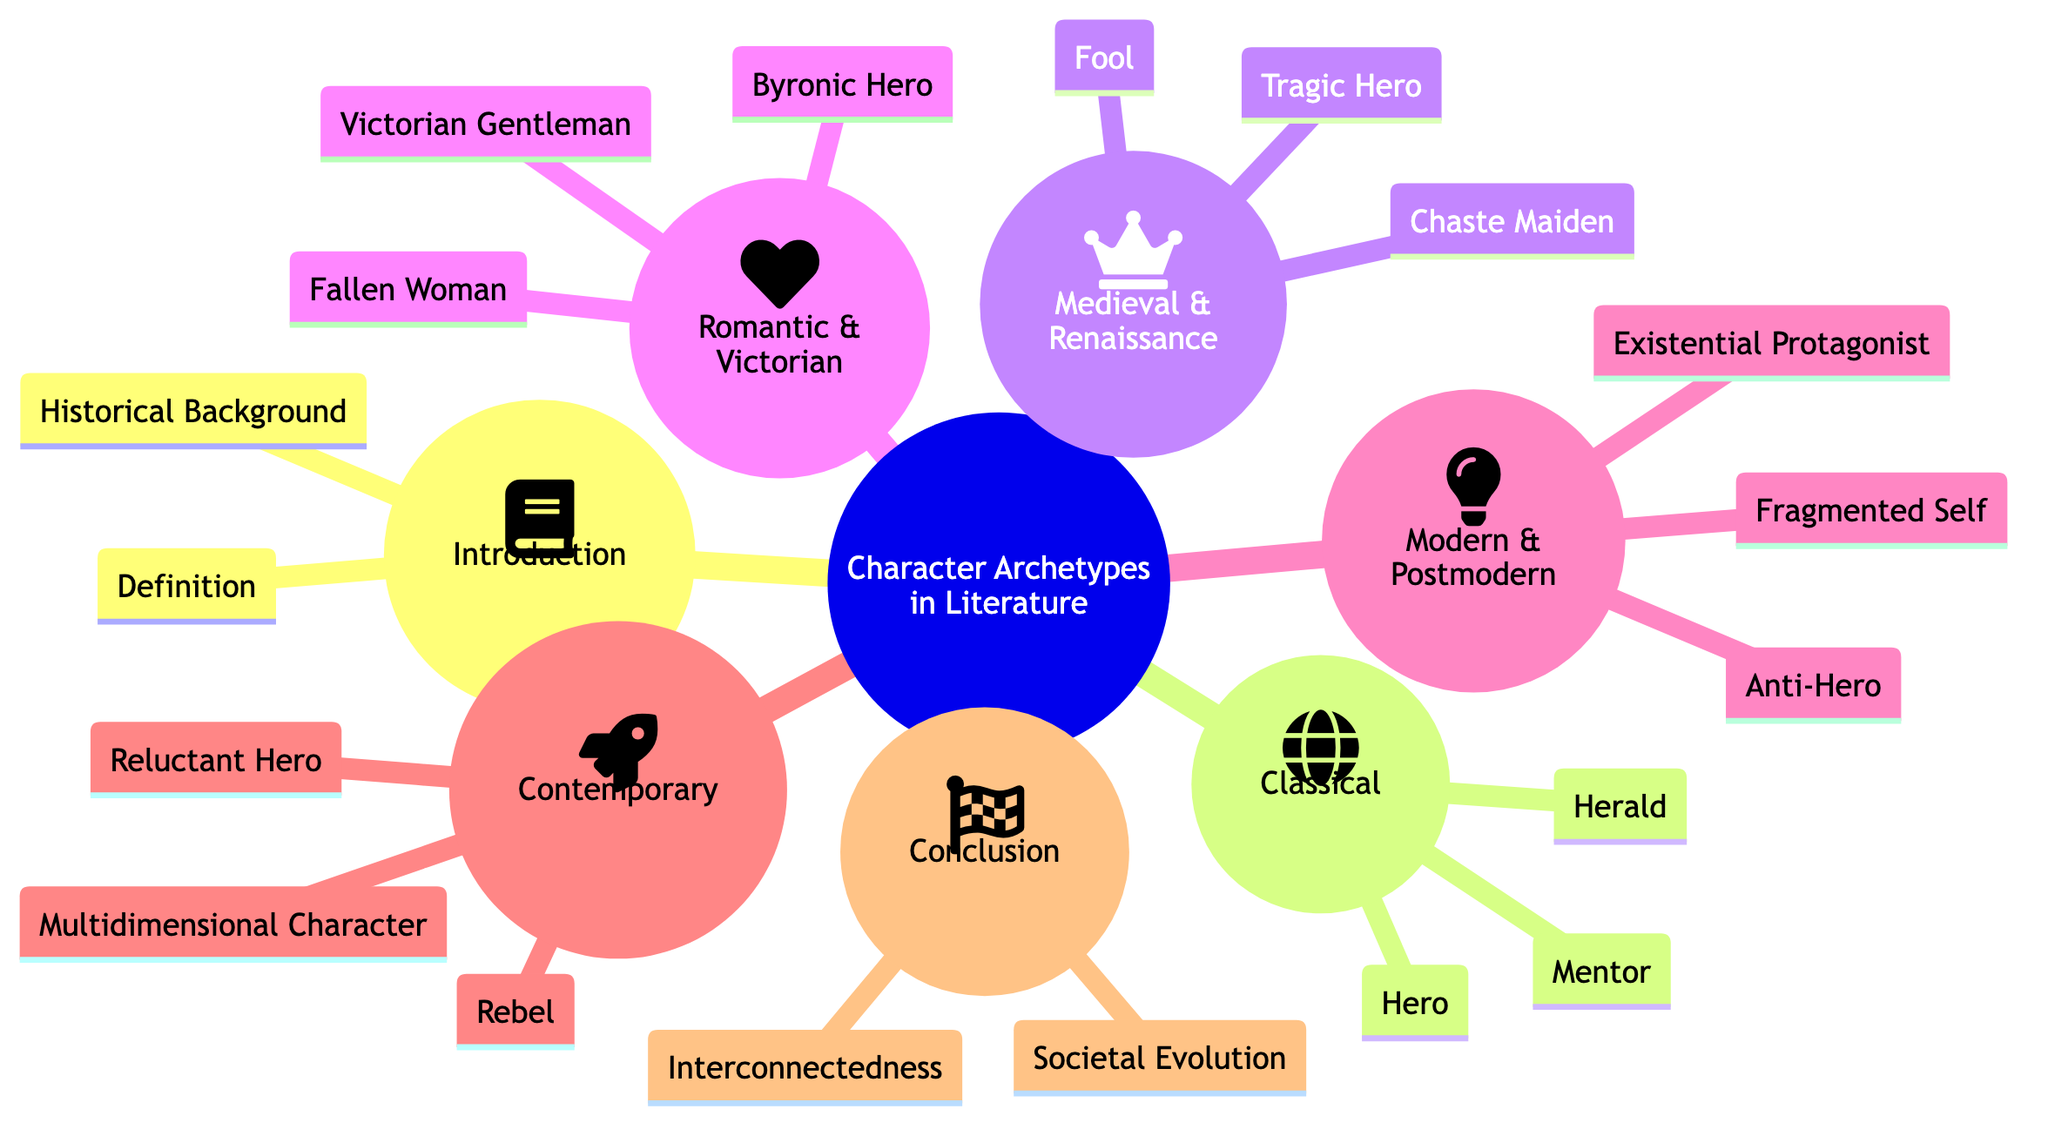What is the main topic of the concept map? The title at the top of the diagram clearly states that the main topic is "The Evolution of Character Archetypes in Literature: Reflecting Human Complexities and Emotions."
Answer: The Evolution of Character Archetypes in Literature: Reflecting Human Complexities and Emotions How many subtopics are present in the diagram? The diagram lists six distinct subtopics branching out from the main topic which can be counted directly from the visual layout.
Answer: Six Name one character archetype from the Classical Archetypes subtopic. Under the subtopic "Classical Archetypes," one of the examples given is "The Hero (Homer's Odysseus)," which can be identified by locating that specific node in the diagram.
Answer: The Hero (Homer's Odysseus) Which archetype is associated with Shakespeare in the Medieval and Renaissance subtopic? The subtopic "Medieval and Renaissance Archetypes" includes "The Tragic Hero (Shakespeare's Hamlet)," indicating a direct connection with Shakespeare.
Answer: The Tragic Hero (Shakespeare's Hamlet) What is one key theme mentioned in the Conclusion subtopic? Within the Conclusion subtopic, the elements listed include "Interconnectedness of Archetypes and Human Emotions" and "Reflection of Societal Evolution," making it clear that both are significant themes in this section.
Answer: Interconnectedness of Archetypes and Human Emotions How do the Modern and Postmodern archetypes differ from Classical archetypes in general? To answer this, we look at the transition from Classic archetypes such as "The Hero" to more complex figures like "The Anti-Hero" and "The Existential Protagonist," showing a shift towards characters reflecting deeper human struggles in Modern and Postmodern literature.
Answer: Complexity Which archetype is described as "The Rebel" and in which subtopic is it found? The term "The Rebel" is specifically listed under the "Contemporary Archetypes" subtopic, directly identifiable from the contents of that section in the diagram.
Answer: The Rebel; Contemporary Archetypes What connects all the character archetypes to human emotions according to the Conclusion? The Conclusion indicates a thematic connection through the phrase "Interconnectedness of Archetypes and Human Emotions," highlighting how various archetypes relate back to human emotional experiences.
Answer: Interconnectedness of Archetypes and Human Emotions 